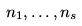<formula> <loc_0><loc_0><loc_500><loc_500>n _ { 1 } , \dots , n _ { s }</formula> 